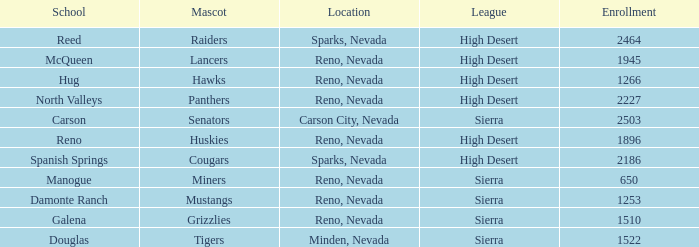Which leagues have Raiders as their mascot? High Desert. 